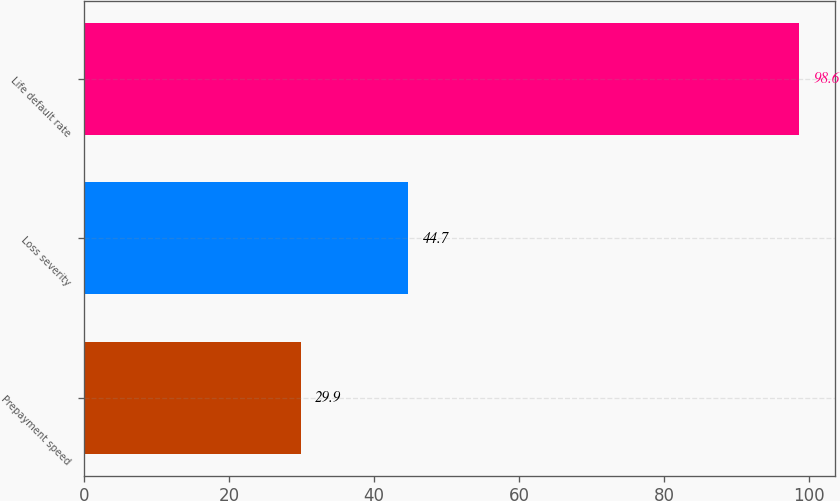<chart> <loc_0><loc_0><loc_500><loc_500><bar_chart><fcel>Prepayment speed<fcel>Loss severity<fcel>Life default rate<nl><fcel>29.9<fcel>44.7<fcel>98.6<nl></chart> 